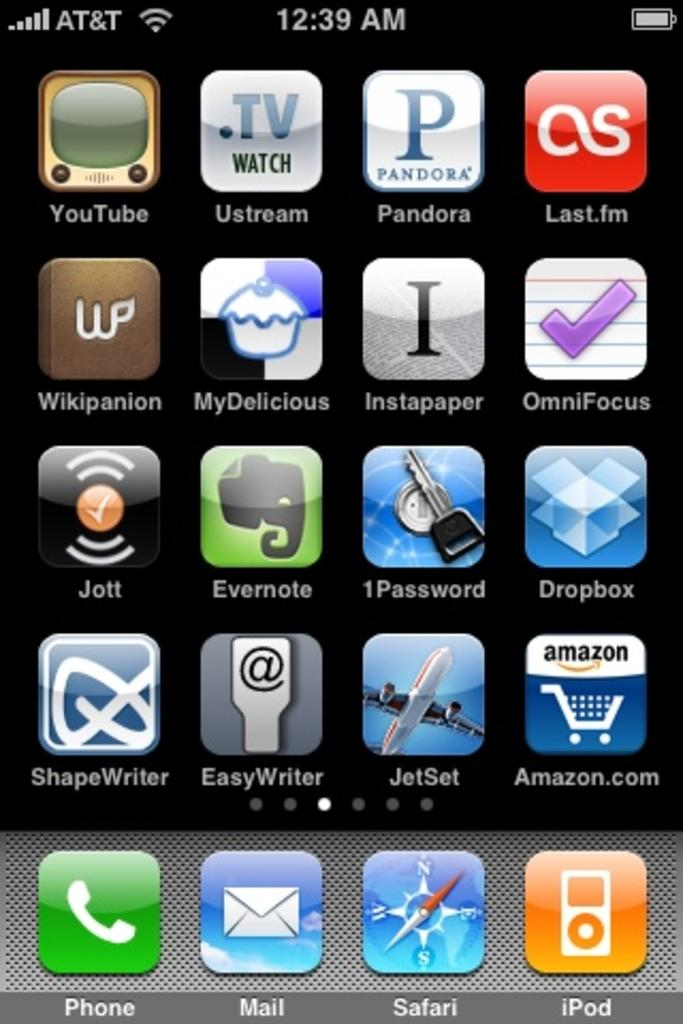Provide a one-sentence caption for the provided image. A phone screen has a selection of apps including Pandora at the top. 